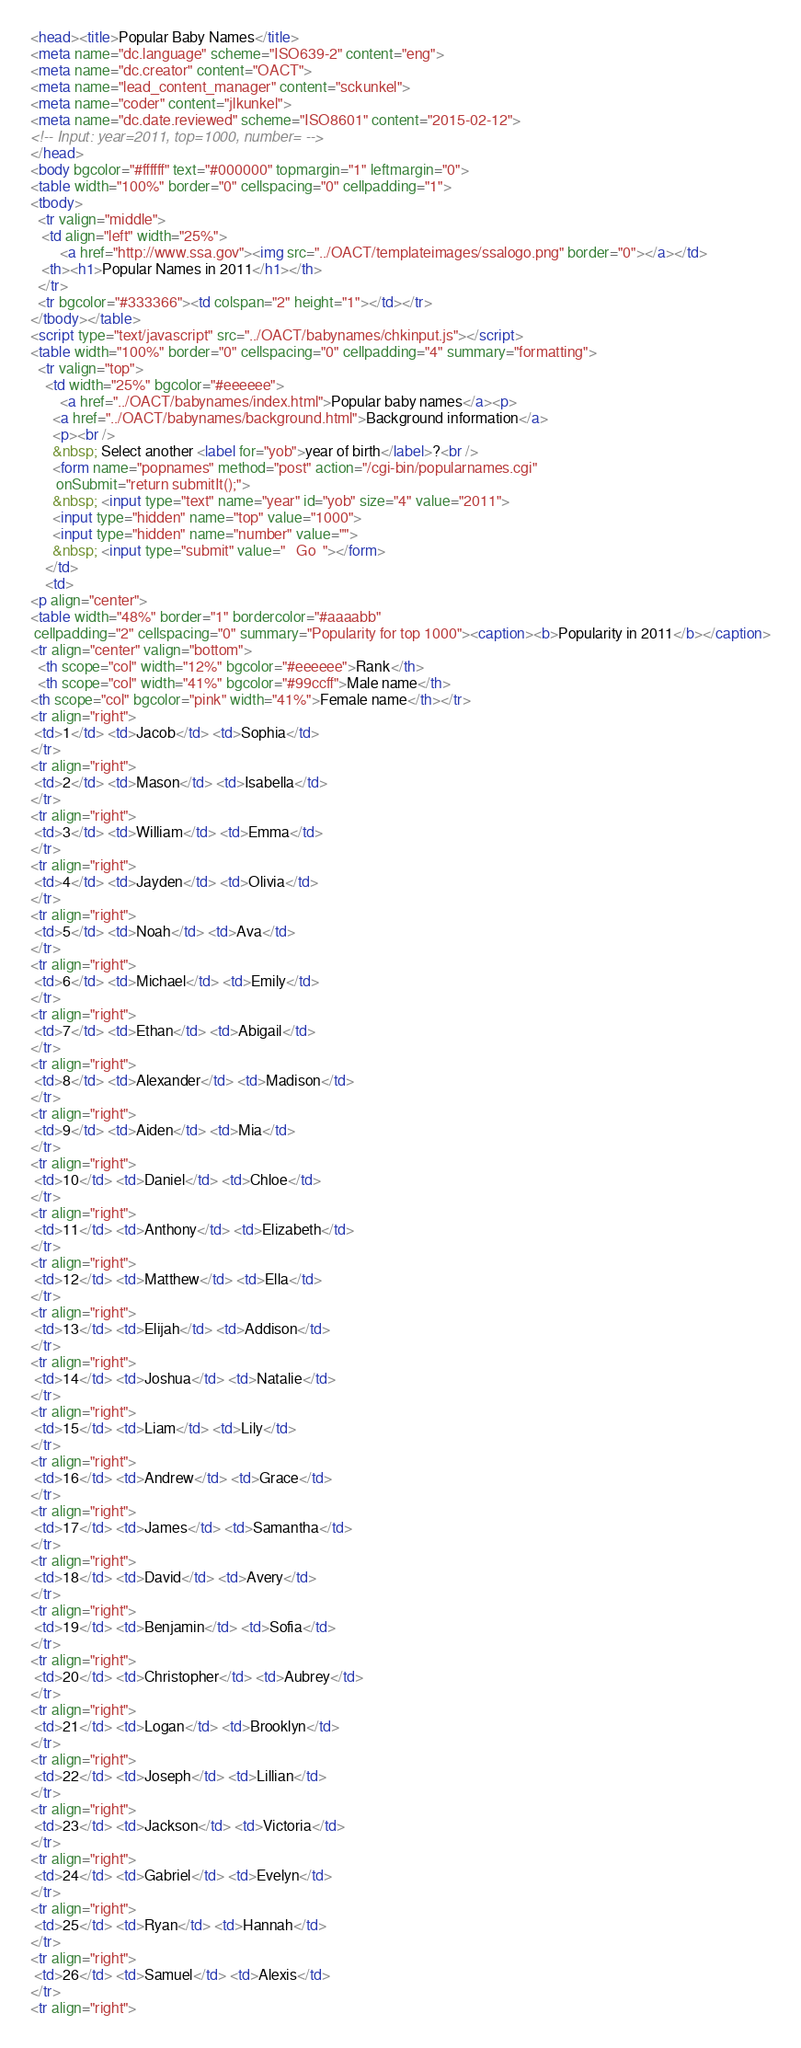Convert code to text. <code><loc_0><loc_0><loc_500><loc_500><_HTML_><head><title>Popular Baby Names</title>
<meta name="dc.language" scheme="ISO639-2" content="eng">
<meta name="dc.creator" content="OACT">
<meta name="lead_content_manager" content="sckunkel">
<meta name="coder" content="jlkunkel">
<meta name="dc.date.reviewed" scheme="ISO8601" content="2015-02-12">
<!-- Input: year=2011, top=1000, number= -->
</head>
<body bgcolor="#ffffff" text="#000000" topmargin="1" leftmargin="0">
<table width="100%" border="0" cellspacing="0" cellpadding="1">
<tbody>
  <tr valign="middle"> 
   <td align="left" width="25%">
		<a href="http://www.ssa.gov"><img src="../OACT/templateimages/ssalogo.png" border="0"></a></td>
   <th><h1>Popular Names in 2011</h1></th>
  </tr>
  <tr bgcolor="#333366"><td colspan="2" height="1"></td></tr>
</tbody></table>
<script type="text/javascript" src="../OACT/babynames/chkinput.js"></script>
<table width="100%" border="0" cellspacing="0" cellpadding="4" summary="formatting">
  <tr valign="top"> 
    <td width="25%" bgcolor="#eeeeee">
		<a href="../OACT/babynames/index.html">Popular baby names</a><p>
      <a href="../OACT/babynames/background.html">Background information</a>
      <p><br />
      &nbsp; Select another <label for="yob">year of birth</label>?<br />      
      <form name="popnames" method="post" action="/cgi-bin/popularnames.cgi"
       onSubmit="return submitIt();">
      &nbsp; <input type="text" name="year" id="yob" size="4" value="2011">
      <input type="hidden" name="top" value="1000">
      <input type="hidden" name="number" value="">
      &nbsp; <input type="submit" value="   Go  "></form>
    </td>
    <td>
<p align="center">
<table width="48%" border="1" bordercolor="#aaaabb"
 cellpadding="2" cellspacing="0" summary="Popularity for top 1000"><caption><b>Popularity in 2011</b></caption>
<tr align="center" valign="bottom">
  <th scope="col" width="12%" bgcolor="#eeeeee">Rank</th>
  <th scope="col" width="41%" bgcolor="#99ccff">Male name</th>
<th scope="col" bgcolor="pink" width="41%">Female name</th></tr>
<tr align="right">
 <td>1</td> <td>Jacob</td> <td>Sophia</td>
</tr>
<tr align="right">
 <td>2</td> <td>Mason</td> <td>Isabella</td>
</tr>
<tr align="right">
 <td>3</td> <td>William</td> <td>Emma</td>
</tr>
<tr align="right">
 <td>4</td> <td>Jayden</td> <td>Olivia</td>
</tr>
<tr align="right">
 <td>5</td> <td>Noah</td> <td>Ava</td>
</tr>
<tr align="right">
 <td>6</td> <td>Michael</td> <td>Emily</td>
</tr>
<tr align="right">
 <td>7</td> <td>Ethan</td> <td>Abigail</td>
</tr>
<tr align="right">
 <td>8</td> <td>Alexander</td> <td>Madison</td>
</tr>
<tr align="right">
 <td>9</td> <td>Aiden</td> <td>Mia</td>
</tr>
<tr align="right">
 <td>10</td> <td>Daniel</td> <td>Chloe</td>
</tr>
<tr align="right">
 <td>11</td> <td>Anthony</td> <td>Elizabeth</td>
</tr>
<tr align="right">
 <td>12</td> <td>Matthew</td> <td>Ella</td>
</tr>
<tr align="right">
 <td>13</td> <td>Elijah</td> <td>Addison</td>
</tr>
<tr align="right">
 <td>14</td> <td>Joshua</td> <td>Natalie</td>
</tr>
<tr align="right">
 <td>15</td> <td>Liam</td> <td>Lily</td>
</tr>
<tr align="right">
 <td>16</td> <td>Andrew</td> <td>Grace</td>
</tr>
<tr align="right">
 <td>17</td> <td>James</td> <td>Samantha</td>
</tr>
<tr align="right">
 <td>18</td> <td>David</td> <td>Avery</td>
</tr>
<tr align="right">
 <td>19</td> <td>Benjamin</td> <td>Sofia</td>
</tr>
<tr align="right">
 <td>20</td> <td>Christopher</td> <td>Aubrey</td>
</tr>
<tr align="right">
 <td>21</td> <td>Logan</td> <td>Brooklyn</td>
</tr>
<tr align="right">
 <td>22</td> <td>Joseph</td> <td>Lillian</td>
</tr>
<tr align="right">
 <td>23</td> <td>Jackson</td> <td>Victoria</td>
</tr>
<tr align="right">
 <td>24</td> <td>Gabriel</td> <td>Evelyn</td>
</tr>
<tr align="right">
 <td>25</td> <td>Ryan</td> <td>Hannah</td>
</tr>
<tr align="right">
 <td>26</td> <td>Samuel</td> <td>Alexis</td>
</tr>
<tr align="right"></code> 